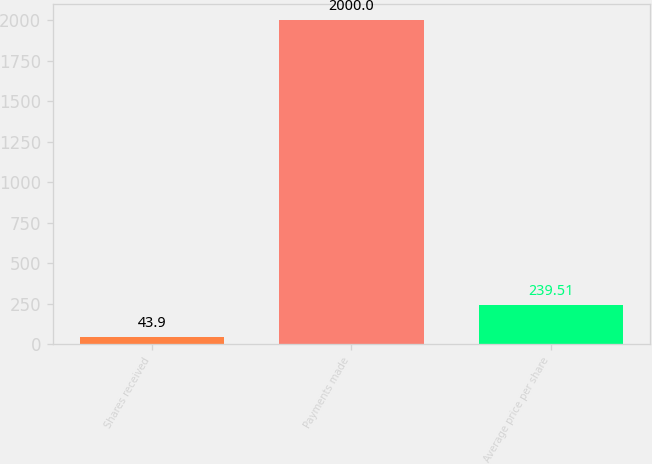<chart> <loc_0><loc_0><loc_500><loc_500><bar_chart><fcel>Shares received<fcel>Payments made<fcel>Average price per share<nl><fcel>43.9<fcel>2000<fcel>239.51<nl></chart> 